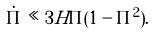<formula> <loc_0><loc_0><loc_500><loc_500>\dot { \Pi } \ll 3 H \Pi ( 1 - \Pi ^ { 2 } ) .</formula> 